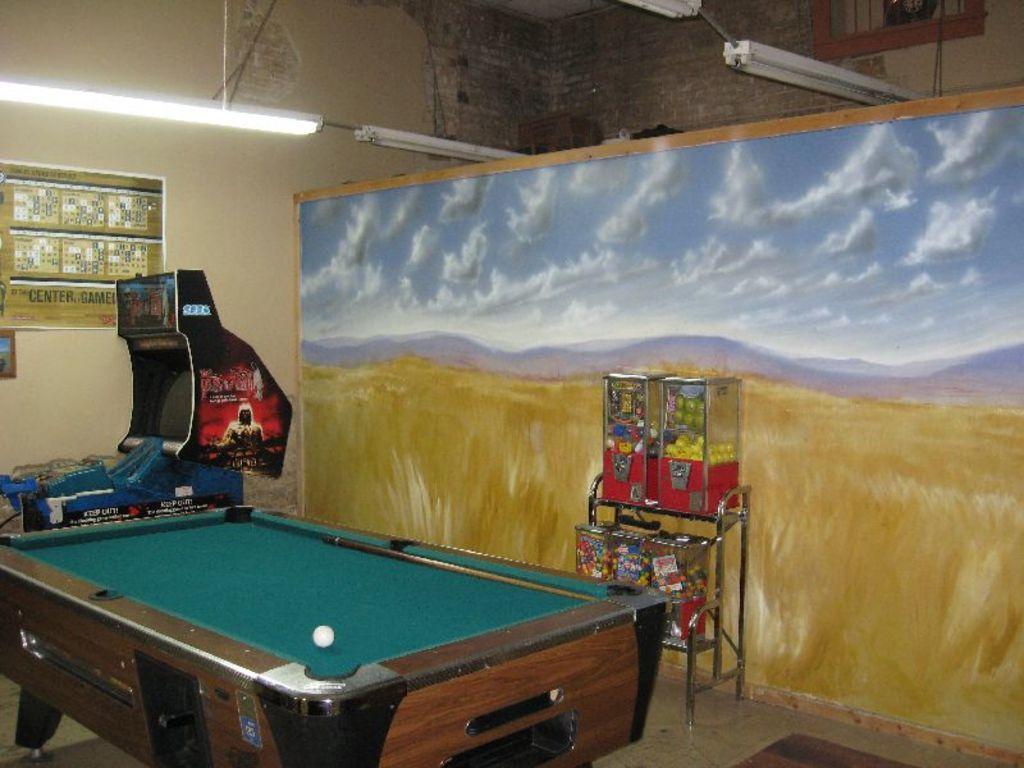Describe this image in one or two sentences. In the image we can see tennis table,on table we can see ball. Back we can see light,machine,some screen and some sign board. And few objects around table. 